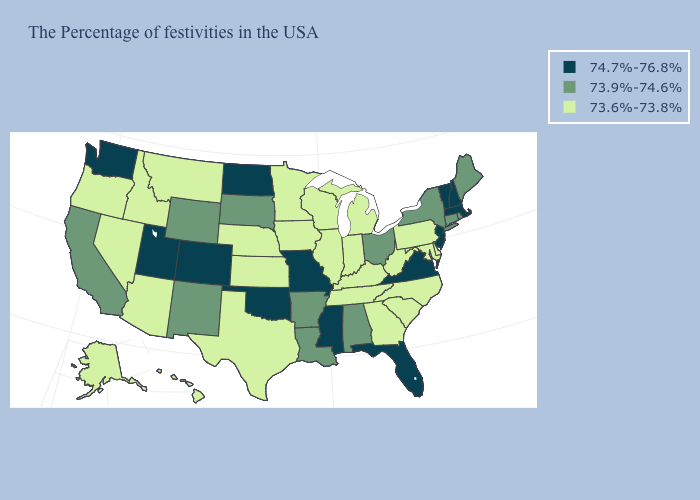Does New Hampshire have the highest value in the Northeast?
Quick response, please. Yes. Which states have the lowest value in the USA?
Give a very brief answer. Delaware, Maryland, Pennsylvania, North Carolina, South Carolina, West Virginia, Georgia, Michigan, Kentucky, Indiana, Tennessee, Wisconsin, Illinois, Minnesota, Iowa, Kansas, Nebraska, Texas, Montana, Arizona, Idaho, Nevada, Oregon, Alaska, Hawaii. Does the first symbol in the legend represent the smallest category?
Write a very short answer. No. Does North Dakota have the highest value in the MidWest?
Quick response, please. Yes. Does Nebraska have the same value as West Virginia?
Quick response, please. Yes. Name the states that have a value in the range 73.9%-74.6%?
Give a very brief answer. Maine, Rhode Island, Connecticut, New York, Ohio, Alabama, Louisiana, Arkansas, South Dakota, Wyoming, New Mexico, California. What is the value of Montana?
Be succinct. 73.6%-73.8%. Name the states that have a value in the range 73.9%-74.6%?
Write a very short answer. Maine, Rhode Island, Connecticut, New York, Ohio, Alabama, Louisiana, Arkansas, South Dakota, Wyoming, New Mexico, California. What is the lowest value in the USA?
Keep it brief. 73.6%-73.8%. What is the value of Texas?
Be succinct. 73.6%-73.8%. What is the value of Utah?
Short answer required. 74.7%-76.8%. Which states have the lowest value in the MidWest?
Write a very short answer. Michigan, Indiana, Wisconsin, Illinois, Minnesota, Iowa, Kansas, Nebraska. What is the lowest value in the USA?
Be succinct. 73.6%-73.8%. How many symbols are there in the legend?
Write a very short answer. 3. Name the states that have a value in the range 73.6%-73.8%?
Be succinct. Delaware, Maryland, Pennsylvania, North Carolina, South Carolina, West Virginia, Georgia, Michigan, Kentucky, Indiana, Tennessee, Wisconsin, Illinois, Minnesota, Iowa, Kansas, Nebraska, Texas, Montana, Arizona, Idaho, Nevada, Oregon, Alaska, Hawaii. 